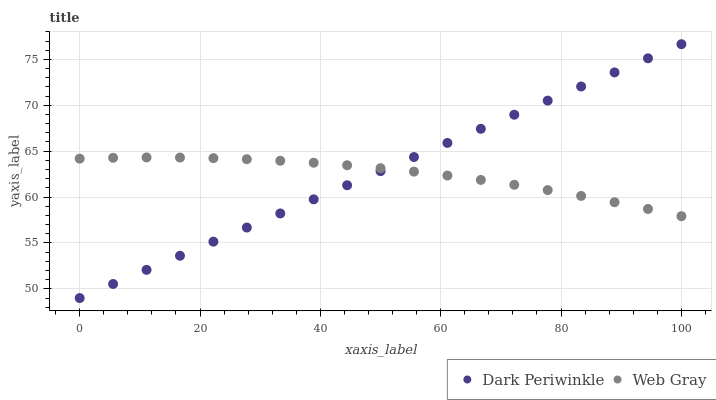Does Web Gray have the minimum area under the curve?
Answer yes or no. Yes. Does Dark Periwinkle have the maximum area under the curve?
Answer yes or no. Yes. Does Dark Periwinkle have the minimum area under the curve?
Answer yes or no. No. Is Dark Periwinkle the smoothest?
Answer yes or no. Yes. Is Web Gray the roughest?
Answer yes or no. Yes. Is Dark Periwinkle the roughest?
Answer yes or no. No. Does Dark Periwinkle have the lowest value?
Answer yes or no. Yes. Does Dark Periwinkle have the highest value?
Answer yes or no. Yes. Does Dark Periwinkle intersect Web Gray?
Answer yes or no. Yes. Is Dark Periwinkle less than Web Gray?
Answer yes or no. No. Is Dark Periwinkle greater than Web Gray?
Answer yes or no. No. 